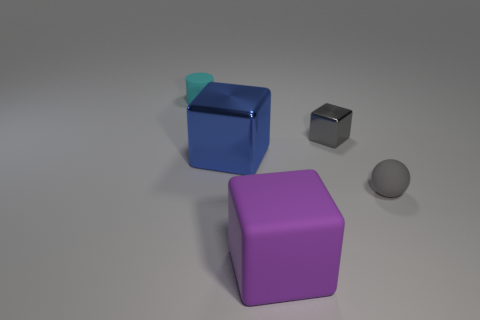Add 2 tiny gray shiny blocks. How many objects exist? 7 Subtract all blue cubes. How many cubes are left? 2 Subtract 2 blocks. How many blocks are left? 1 Subtract all brown blocks. How many red balls are left? 0 Subtract all purple cylinders. Subtract all cyan spheres. How many cylinders are left? 1 Subtract all gray objects. Subtract all cyan things. How many objects are left? 2 Add 4 small matte objects. How many small matte objects are left? 6 Add 1 big cylinders. How many big cylinders exist? 1 Subtract 0 yellow cylinders. How many objects are left? 5 Subtract all cubes. How many objects are left? 2 